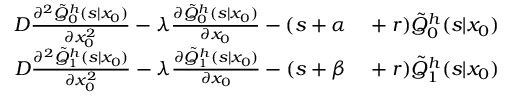Convert formula to latex. <formula><loc_0><loc_0><loc_500><loc_500>\begin{array} { r l } { D \frac { \partial ^ { 2 } \tilde { Q } _ { 0 } ^ { h } ( s | x _ { 0 } ) } { \partial x _ { 0 } ^ { 2 } } - \lambda \frac { \partial \tilde { Q } _ { 0 } ^ { h } ( s | x _ { 0 } ) } { \partial x _ { 0 } } - ( s + \alpha } & + r ) \tilde { Q } _ { 0 } ^ { h } ( s | x _ { 0 } ) } \\ { D \frac { \partial ^ { 2 } \tilde { Q } _ { 1 } ^ { h } ( s | x _ { 0 } ) } { \partial x _ { 0 } ^ { 2 } } - \lambda \frac { \partial \tilde { Q } _ { 1 } ^ { h } ( s | x _ { 0 } ) } { \partial x _ { 0 } } - ( s + \beta } & + r ) \tilde { Q } _ { 1 } ^ { h } ( s | x _ { 0 } ) } \end{array}</formula> 